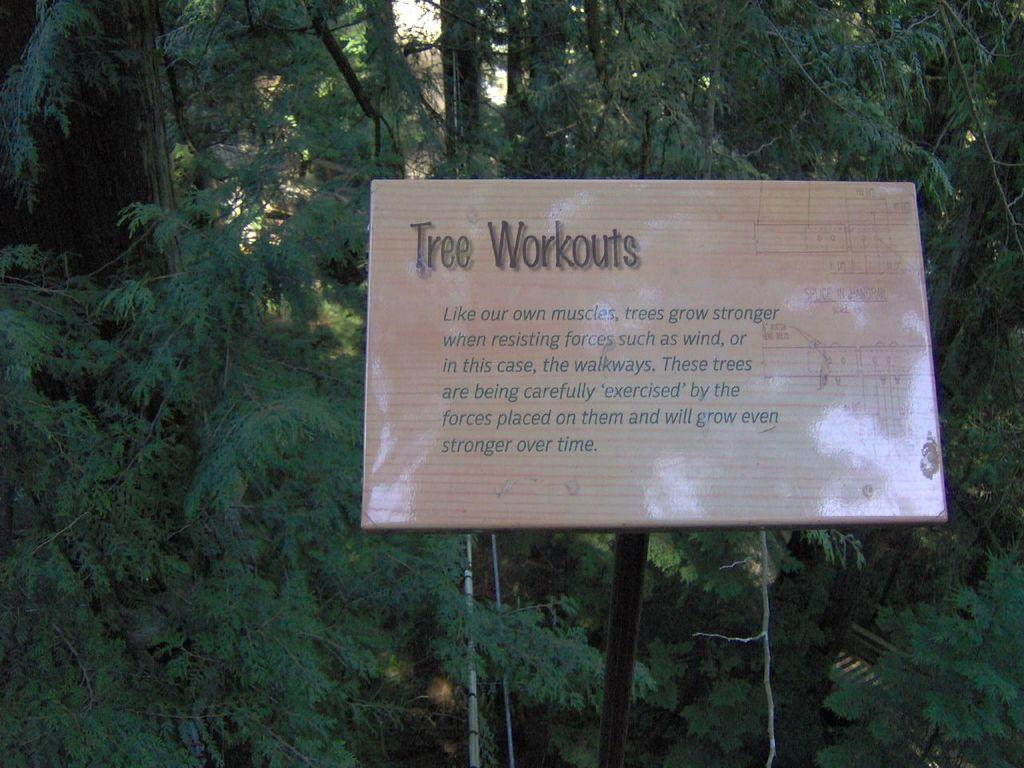What is the main object in the image? There is a pole in the image. What is attached to the pole? There is a cream-colored board on the pole. What can be seen on the board? Something is written on the board. What can be seen in the distance in the image? There are trees visible in the background of the image. Where is the beggar sitting near the pole in the image? There is no beggar present in the image. What type of dock can be seen near the pole in the image? There is no dock present in the image. 